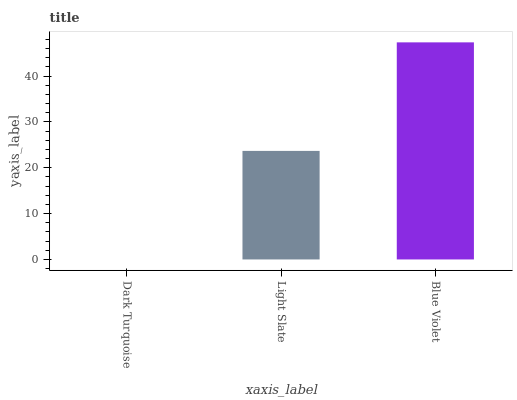Is Dark Turquoise the minimum?
Answer yes or no. Yes. Is Blue Violet the maximum?
Answer yes or no. Yes. Is Light Slate the minimum?
Answer yes or no. No. Is Light Slate the maximum?
Answer yes or no. No. Is Light Slate greater than Dark Turquoise?
Answer yes or no. Yes. Is Dark Turquoise less than Light Slate?
Answer yes or no. Yes. Is Dark Turquoise greater than Light Slate?
Answer yes or no. No. Is Light Slate less than Dark Turquoise?
Answer yes or no. No. Is Light Slate the high median?
Answer yes or no. Yes. Is Light Slate the low median?
Answer yes or no. Yes. Is Blue Violet the high median?
Answer yes or no. No. Is Dark Turquoise the low median?
Answer yes or no. No. 